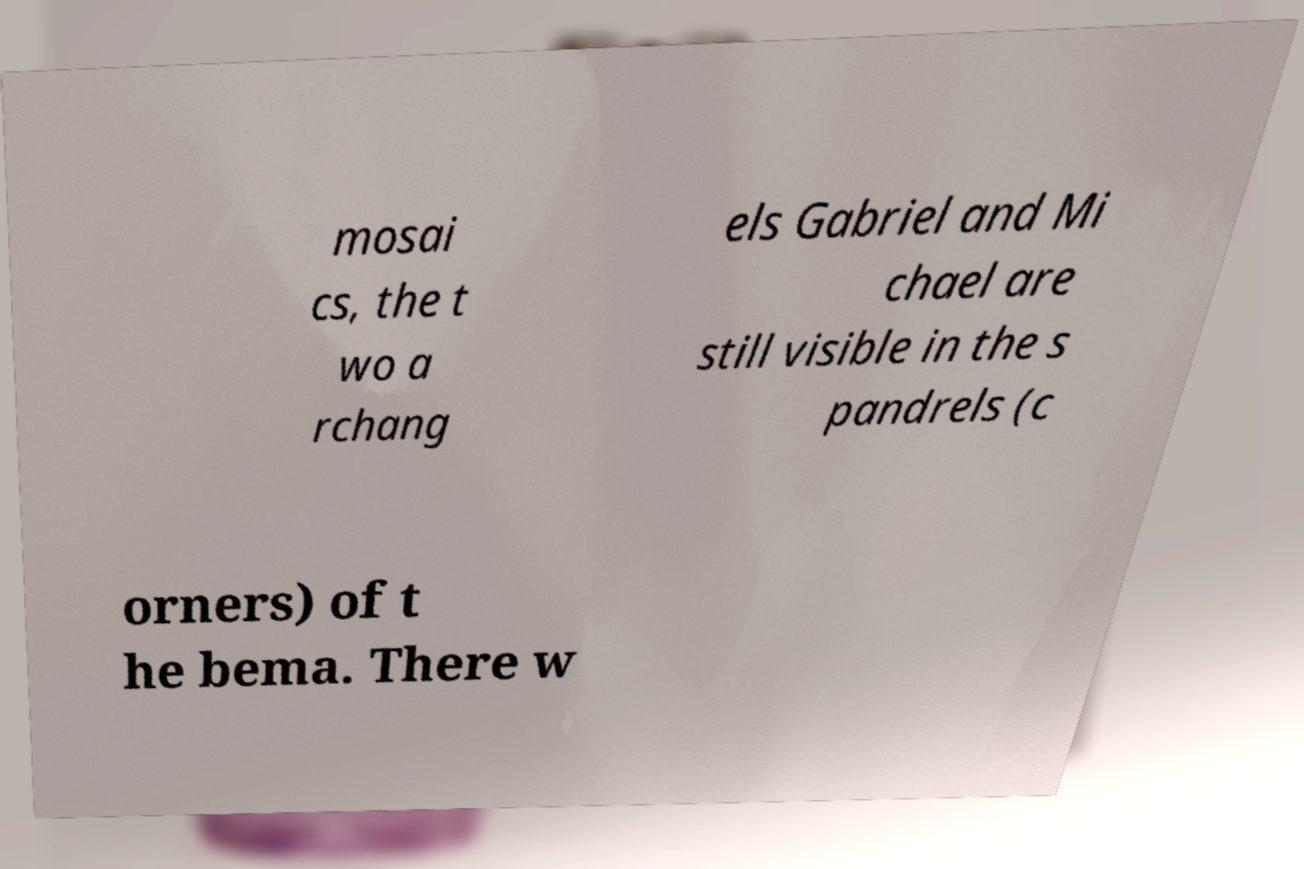For documentation purposes, I need the text within this image transcribed. Could you provide that? mosai cs, the t wo a rchang els Gabriel and Mi chael are still visible in the s pandrels (c orners) of t he bema. There w 